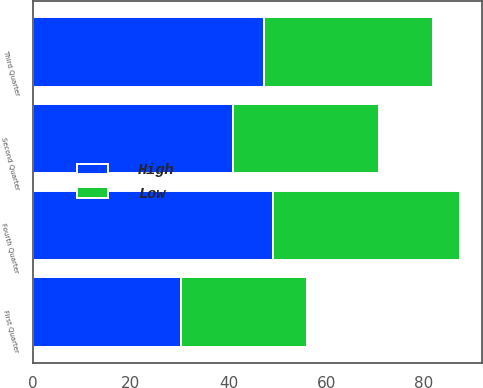<chart> <loc_0><loc_0><loc_500><loc_500><stacked_bar_chart><ecel><fcel>First Quarter<fcel>Second Quarter<fcel>Third Quarter<fcel>Fourth Quarter<nl><fcel>High<fcel>30.26<fcel>40.9<fcel>47.33<fcel>49.18<nl><fcel>Low<fcel>25.84<fcel>29.91<fcel>34.43<fcel>38.2<nl></chart> 